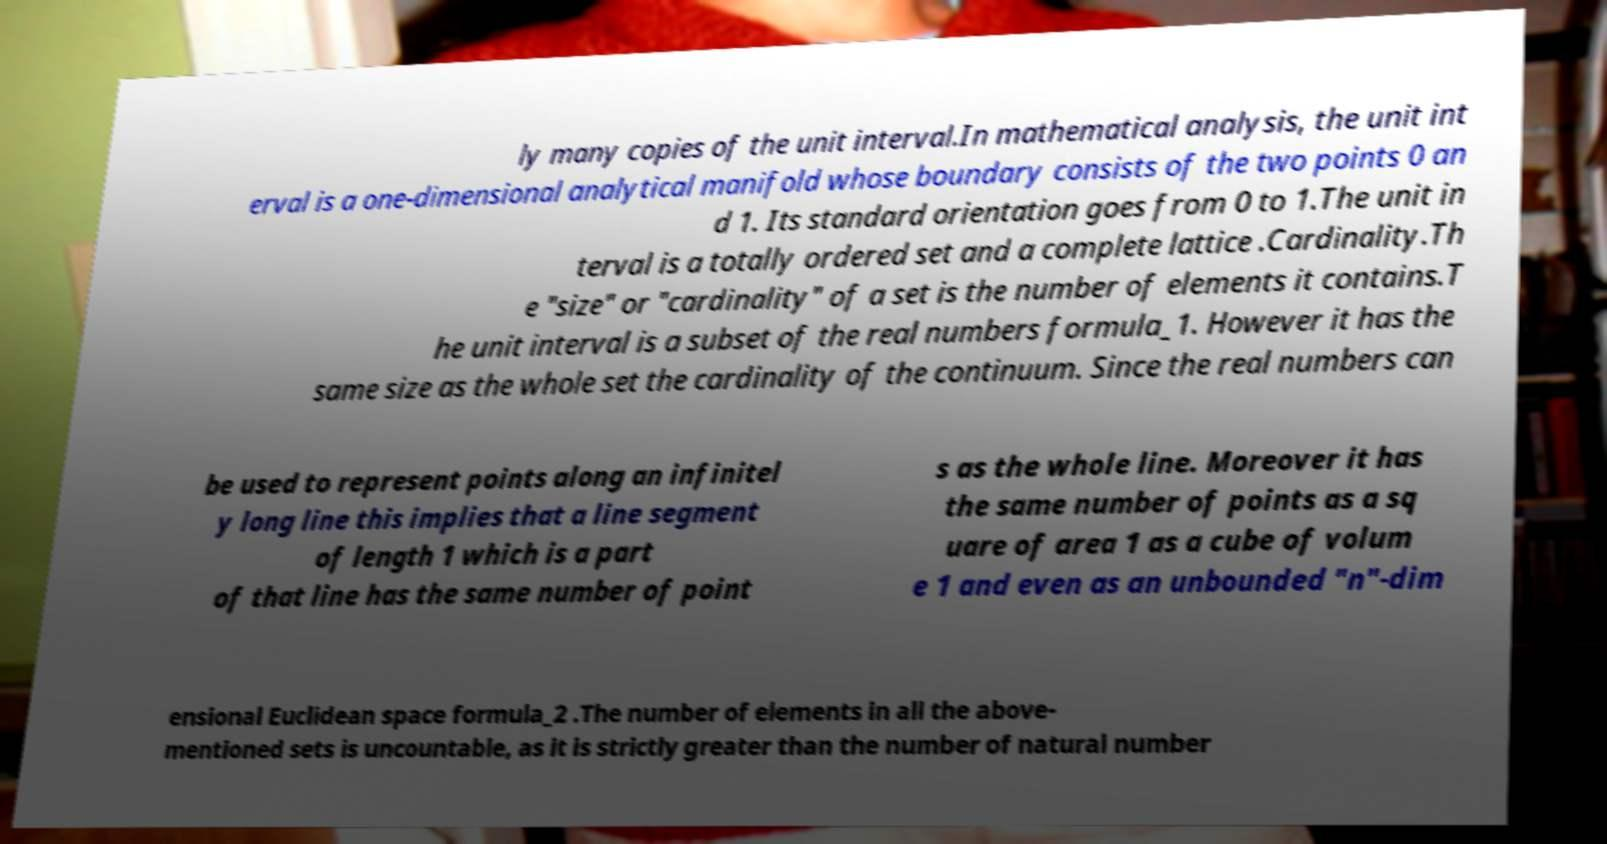Could you extract and type out the text from this image? ly many copies of the unit interval.In mathematical analysis, the unit int erval is a one-dimensional analytical manifold whose boundary consists of the two points 0 an d 1. Its standard orientation goes from 0 to 1.The unit in terval is a totally ordered set and a complete lattice .Cardinality.Th e "size" or "cardinality" of a set is the number of elements it contains.T he unit interval is a subset of the real numbers formula_1. However it has the same size as the whole set the cardinality of the continuum. Since the real numbers can be used to represent points along an infinitel y long line this implies that a line segment of length 1 which is a part of that line has the same number of point s as the whole line. Moreover it has the same number of points as a sq uare of area 1 as a cube of volum e 1 and even as an unbounded "n"-dim ensional Euclidean space formula_2 .The number of elements in all the above- mentioned sets is uncountable, as it is strictly greater than the number of natural number 